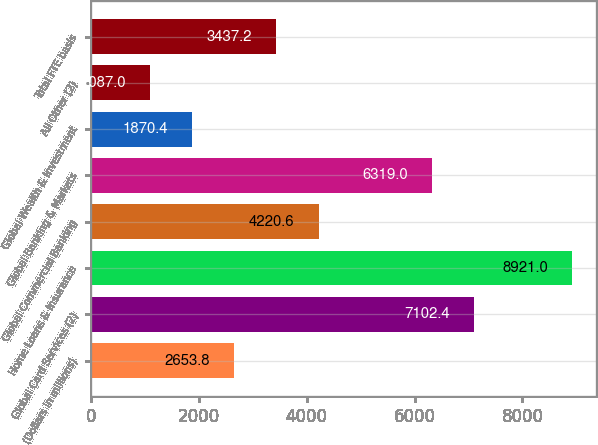<chart> <loc_0><loc_0><loc_500><loc_500><bar_chart><fcel>(Dollars in millions)<fcel>Global Card Services (2)<fcel>Home Loans & Insurance<fcel>Global Commercial Banking<fcel>Global Banking & Markets<fcel>Global Wealth & Investment<fcel>All Other (2)<fcel>Total FTE basis<nl><fcel>2653.8<fcel>7102.4<fcel>8921<fcel>4220.6<fcel>6319<fcel>1870.4<fcel>1087<fcel>3437.2<nl></chart> 